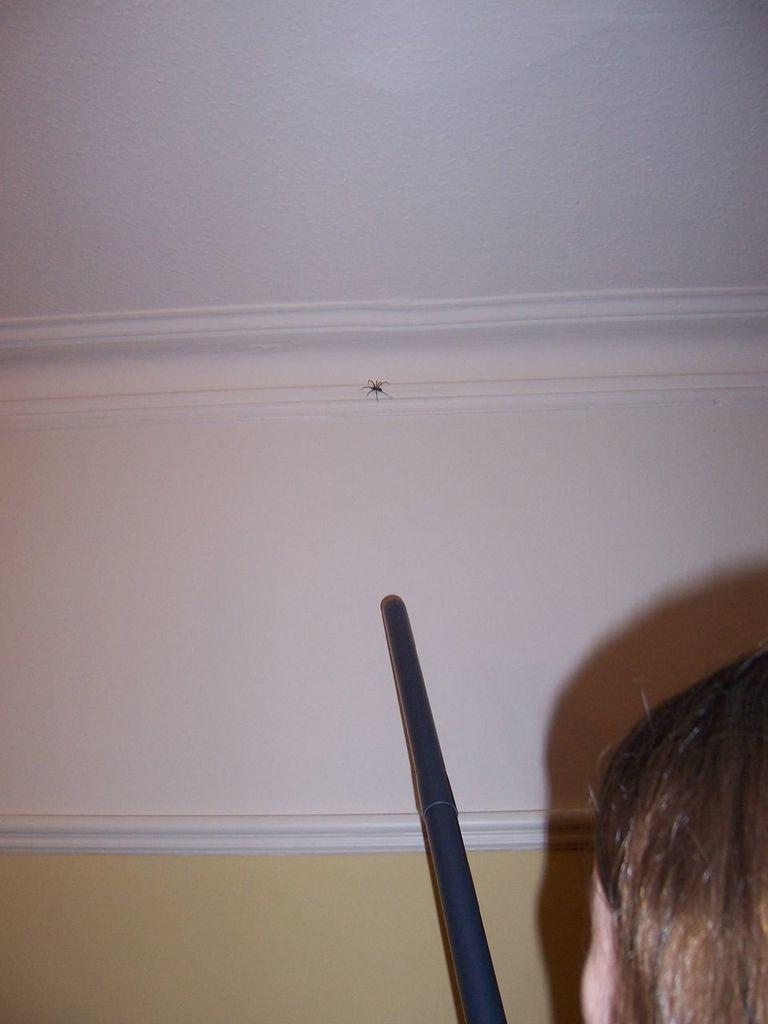What is the main subject of the image? There is a person's head in the image. What object is located in the front of the image? There is a stick in the front of the image. What can be seen in the background of the image? There is a wall in the background of the image. Are there any living creatures visible in the image? Yes, there is a spider on the wall. What type of lettuce is growing on the wall in the image? There is no lettuce present in the image; it features a spider on the wall. How many zippers can be seen on the person's head in the image? There are no zippers visible on the person's head in the image. 